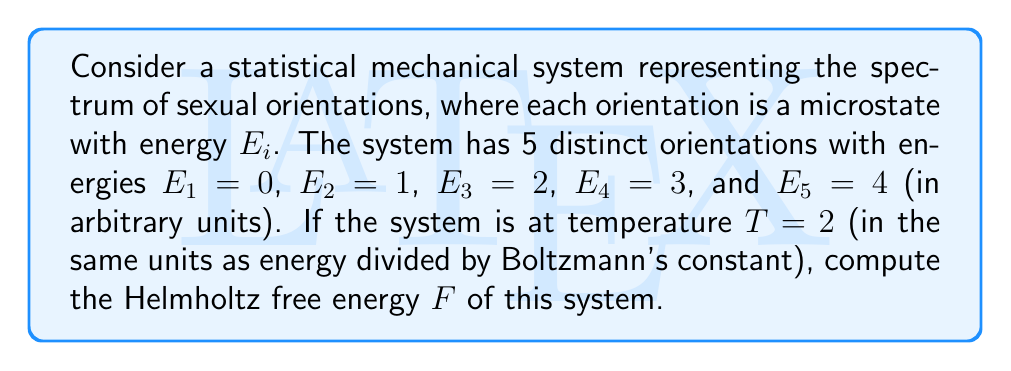Teach me how to tackle this problem. To compute the Helmholtz free energy $F$, we'll follow these steps:

1) The Helmholtz free energy is given by:
   $$F = -kT \ln Z$$
   where $k$ is Boltzmann's constant (which we'll take as 1 in our units), $T$ is temperature, and $Z$ is the partition function.

2) The partition function $Z$ is defined as:
   $$Z = \sum_i e^{-\beta E_i}$$
   where $\beta = \frac{1}{kT}$

3) Calculate $\beta$:
   $$\beta = \frac{1}{kT} = \frac{1}{2}$$

4) Now, let's calculate $Z$:
   $$Z = e^{-\frac{1}{2}\cdot 0} + e^{-\frac{1}{2}\cdot 1} + e^{-\frac{1}{2}\cdot 2} + e^{-\frac{1}{2}\cdot 3} + e^{-\frac{1}{2}\cdot 4}$$
   $$Z = 1 + e^{-\frac{1}{2}} + e^{-1} + e^{-\frac{3}{2}} + e^{-2}$$

5) Evaluate $Z$ numerically:
   $$Z \approx 3.29744$$

6) Now we can calculate $F$:
   $$F = -kT \ln Z = -2 \ln(3.29744) \approx -2.38722$$

Thus, the Helmholtz free energy of this system representing the spectrum of sexual orientations is approximately -2.38722 in our chosen units.
Answer: $F \approx -2.38722$ (in arbitrary energy units) 